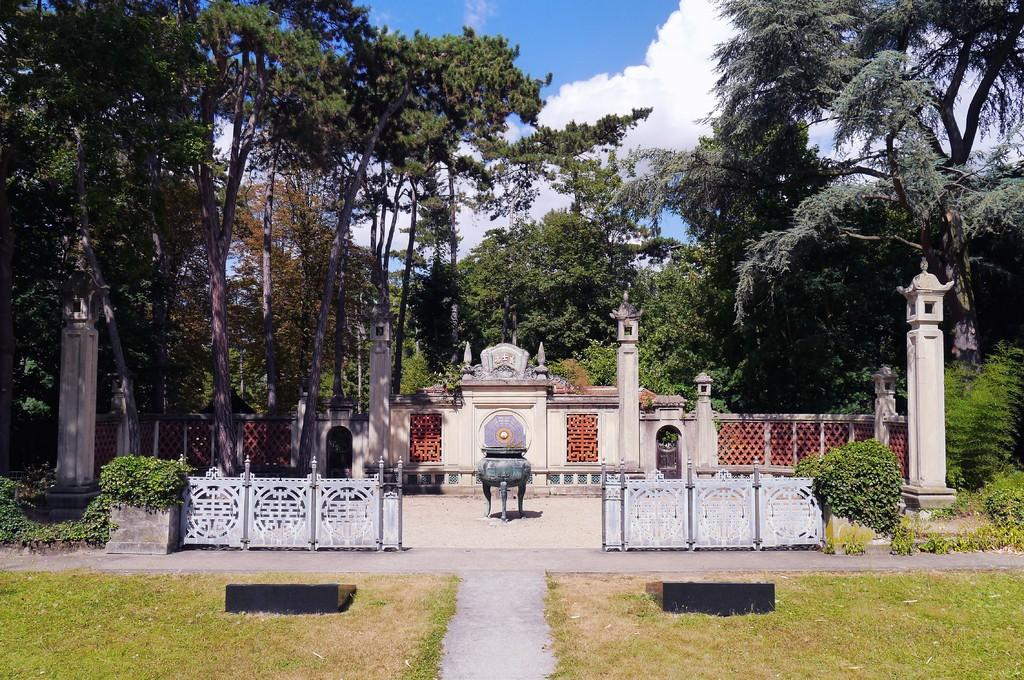What type of vegetation is in the foreground of the image? There is grass in the foreground of the image. What feature is present for walking through the grass? There is a path between the grass for walking. How many pillars can be seen in the image? There are four pillars in the image. What type of structure is present in the image? There is a constructed designer wall in the image. What can be seen at the top of the image? Trees and the sky are visible at the top of the image. What is present in the sky? Clouds are present in the sky. Can you tell me how many kitties are playing on the designer wall in the image? There are no kitties present in the image; it only features grass, a path, pillars, a designer wall, trees, the sky, and clouds. What type of destruction can be seen on the designer wall in the image? There is no destruction present on the designer wall in the image. 